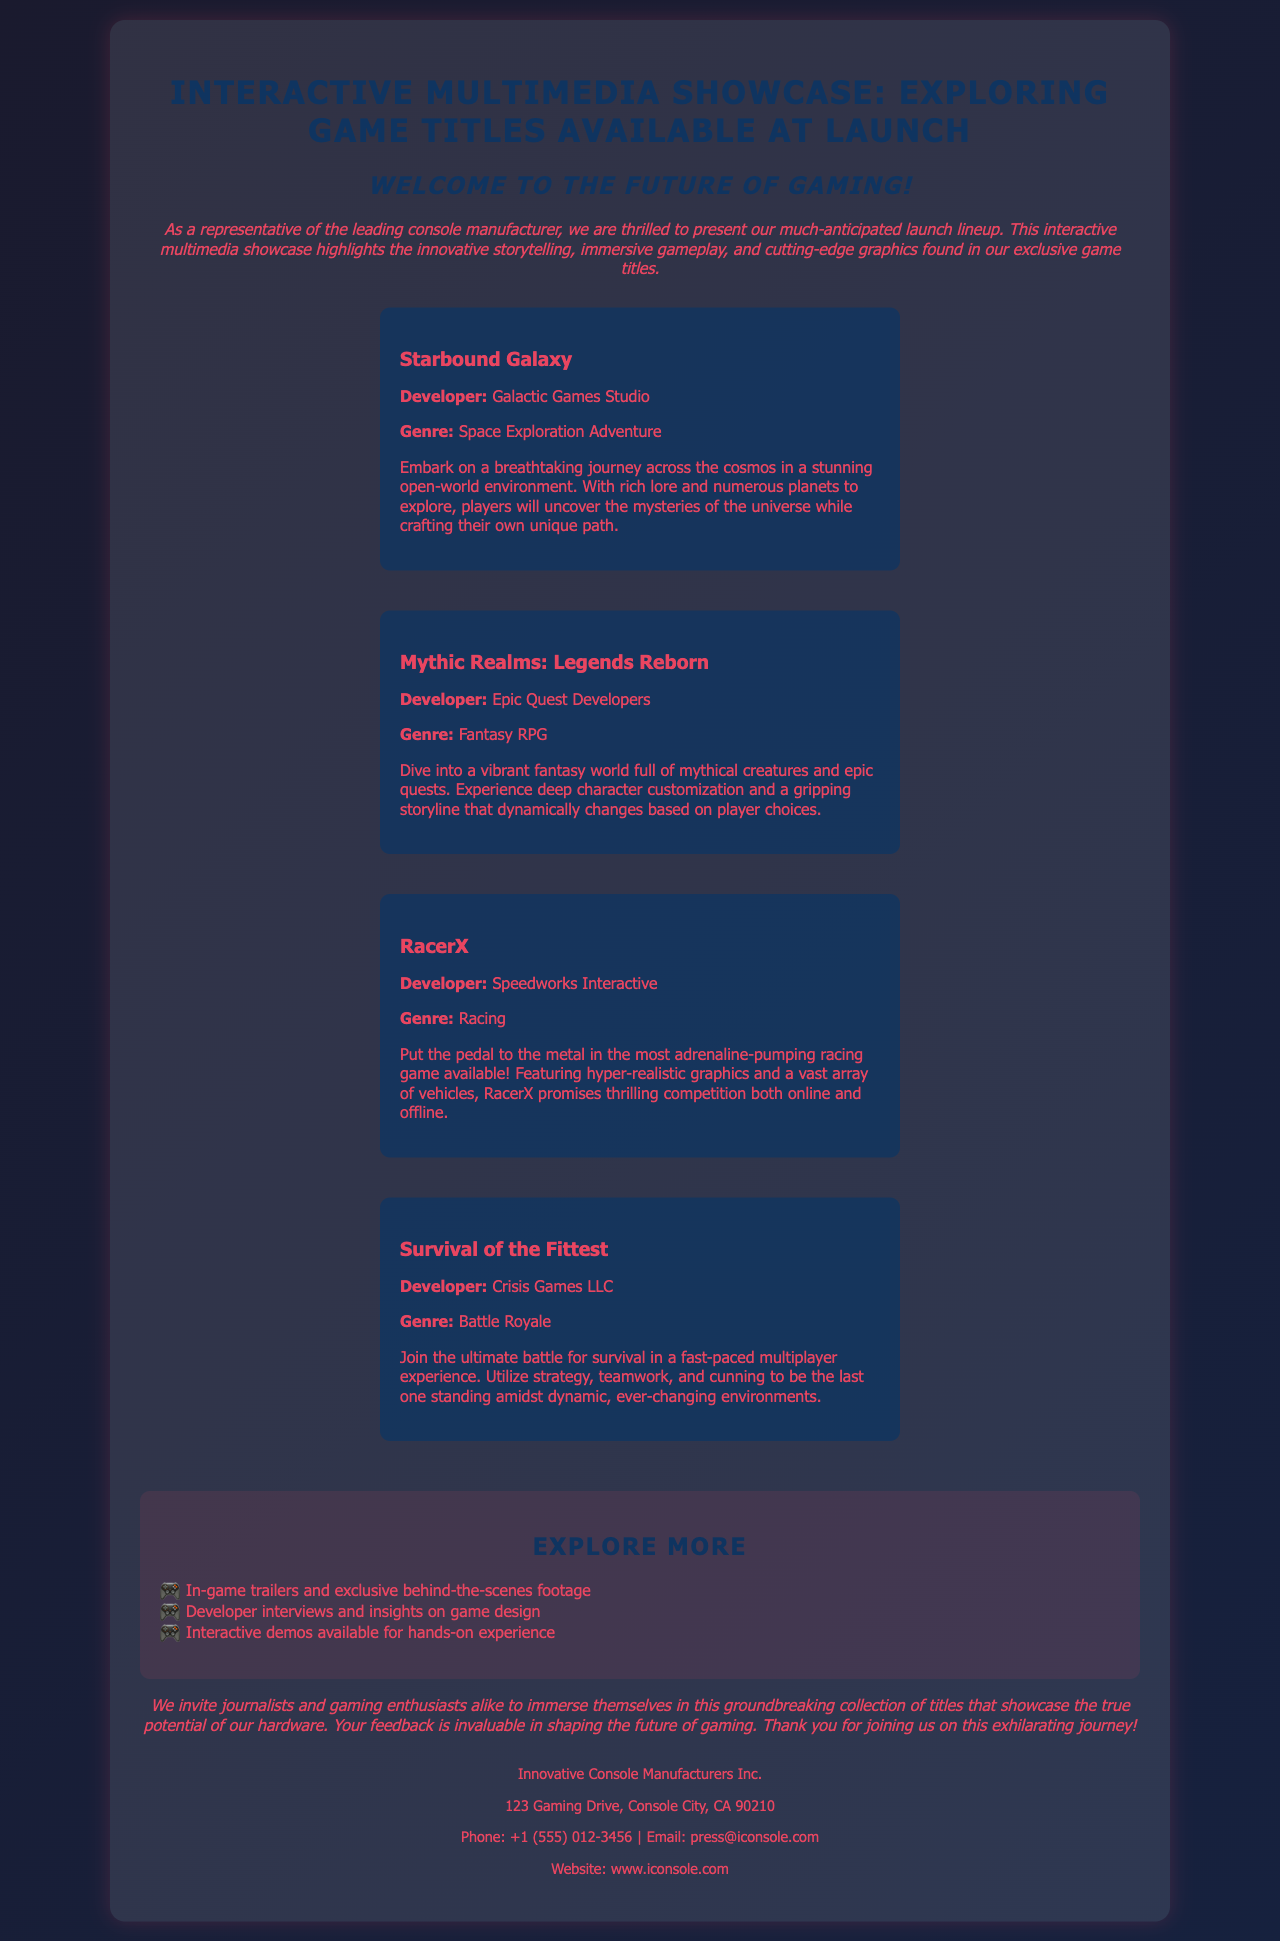What is the title of the showcase? The title is prominently displayed at the top of the document.
Answer: Interactive Multimedia Showcase: Exploring Game Titles Available at Launch Who developed "Starbound Galaxy"? The developer's name is mentioned under the title of the game in the document.
Answer: Galactic Games Studio What genre is "Mythic Realms: Legends Reborn"? The genre is specified in the description of the game.
Answer: Fantasy RPG How many featured games are listed in the document? The document explicitly mentions four games in the featured section.
Answer: Four What type of experience does "Survival of the Fittest" offer? The type of multiplayer experience is described in the game details.
Answer: Battle Royale What does the interactive feature section include? The section lists various elements present in the interactive features.
Answer: In-game trailers and exclusive behind-the-scenes footage What is the purpose of the closing note? The closing note summarizes the invitation and expresses gratitude to attendees.
Answer: To invite journalists and gaming enthusiasts What is the contact email for the console company? The email address is provided in the contact information section.
Answer: press@iconsole.com 